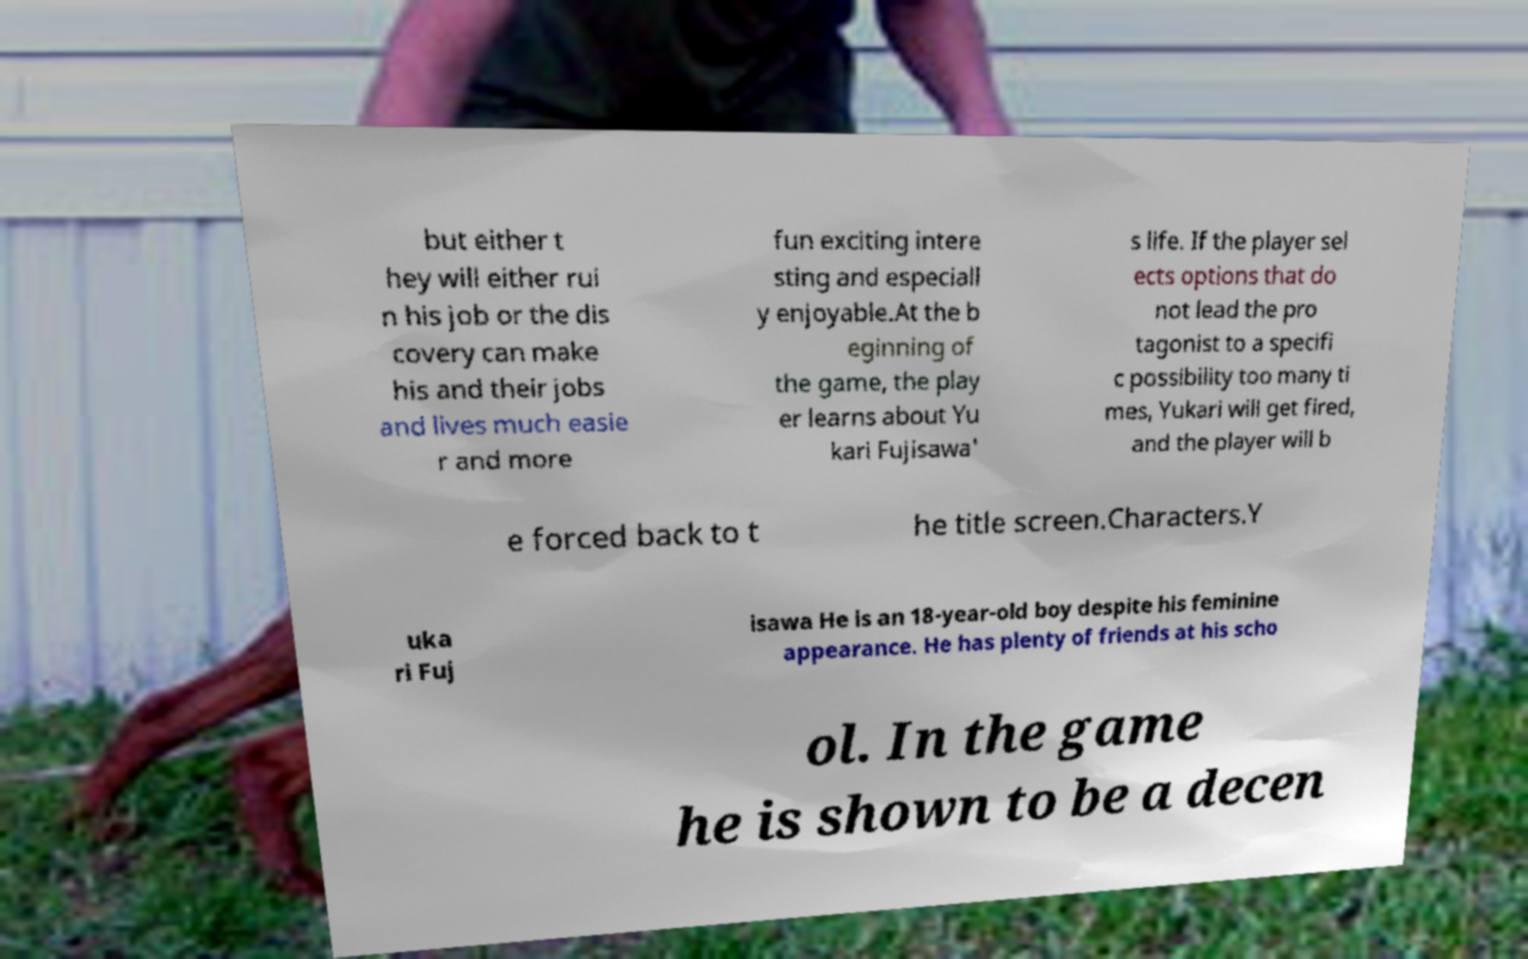Could you extract and type out the text from this image? but either t hey will either rui n his job or the dis covery can make his and their jobs and lives much easie r and more fun exciting intere sting and especiall y enjoyable.At the b eginning of the game, the play er learns about Yu kari Fujisawa' s life. If the player sel ects options that do not lead the pro tagonist to a specifi c possibility too many ti mes, Yukari will get fired, and the player will b e forced back to t he title screen.Characters.Y uka ri Fuj isawa He is an 18-year-old boy despite his feminine appearance. He has plenty of friends at his scho ol. In the game he is shown to be a decen 